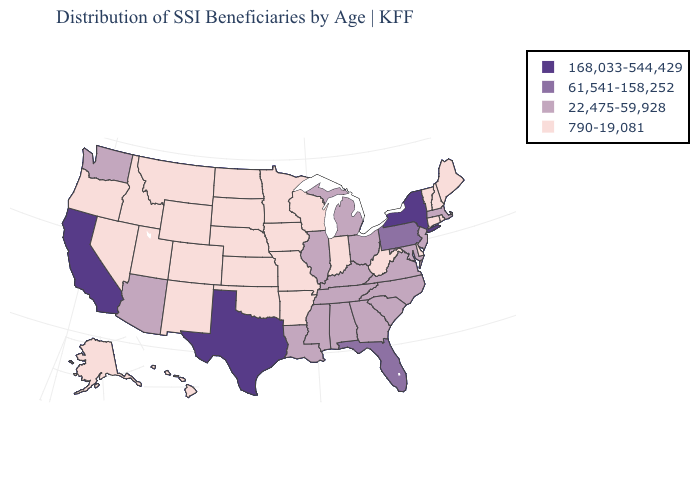Does Washington have a lower value than California?
Short answer required. Yes. Name the states that have a value in the range 168,033-544,429?
Concise answer only. California, New York, Texas. Does the map have missing data?
Be succinct. No. Name the states that have a value in the range 22,475-59,928?
Write a very short answer. Alabama, Arizona, Georgia, Illinois, Kentucky, Louisiana, Maryland, Massachusetts, Michigan, Mississippi, New Jersey, North Carolina, Ohio, South Carolina, Tennessee, Virginia, Washington. What is the lowest value in the MidWest?
Keep it brief. 790-19,081. What is the value of North Carolina?
Quick response, please. 22,475-59,928. Does the first symbol in the legend represent the smallest category?
Short answer required. No. What is the value of New Jersey?
Concise answer only. 22,475-59,928. Name the states that have a value in the range 61,541-158,252?
Short answer required. Florida, Pennsylvania. What is the value of Alaska?
Concise answer only. 790-19,081. Does Alabama have a lower value than Minnesota?
Concise answer only. No. What is the value of Wyoming?
Keep it brief. 790-19,081. What is the value of Mississippi?
Be succinct. 22,475-59,928. What is the highest value in the USA?
Answer briefly. 168,033-544,429. 